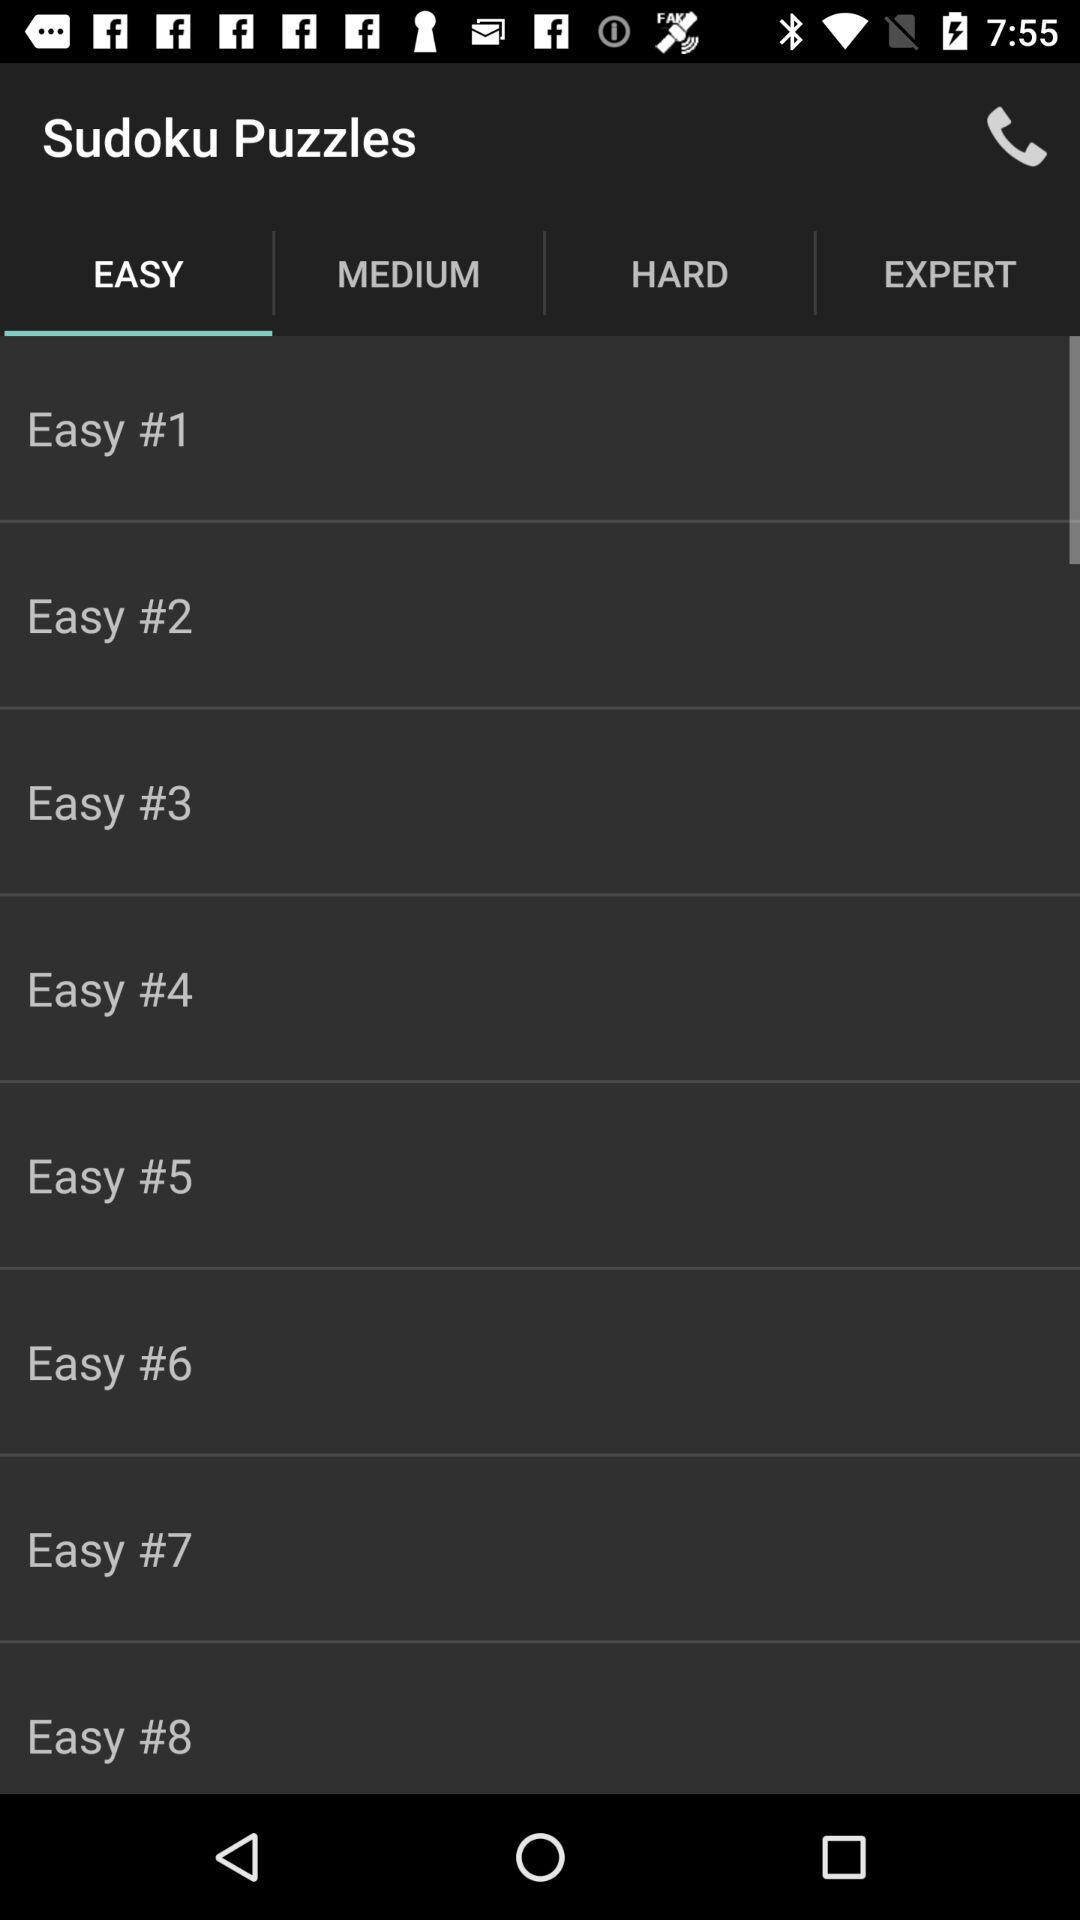How many easy puzzles are there?
Answer the question using a single word or phrase. 8 